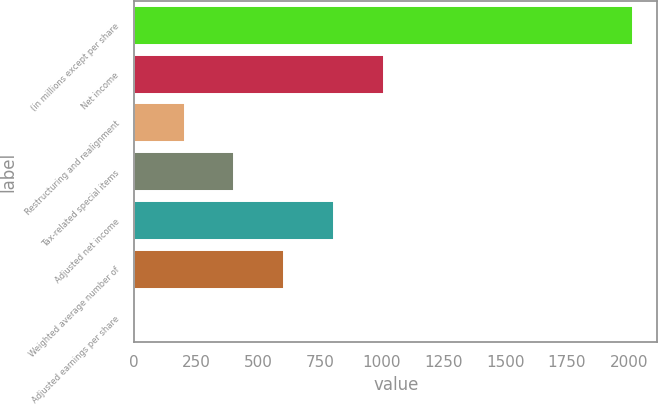Convert chart to OTSL. <chart><loc_0><loc_0><loc_500><loc_500><bar_chart><fcel>(in millions except per share<fcel>Net income<fcel>Restructuring and realignment<fcel>Tax-related special items<fcel>Adjusted net income<fcel>Weighted average number of<fcel>Adjusted earnings per share<nl><fcel>2015<fcel>1008.44<fcel>203.17<fcel>404.49<fcel>807.12<fcel>605.81<fcel>1.85<nl></chart> 